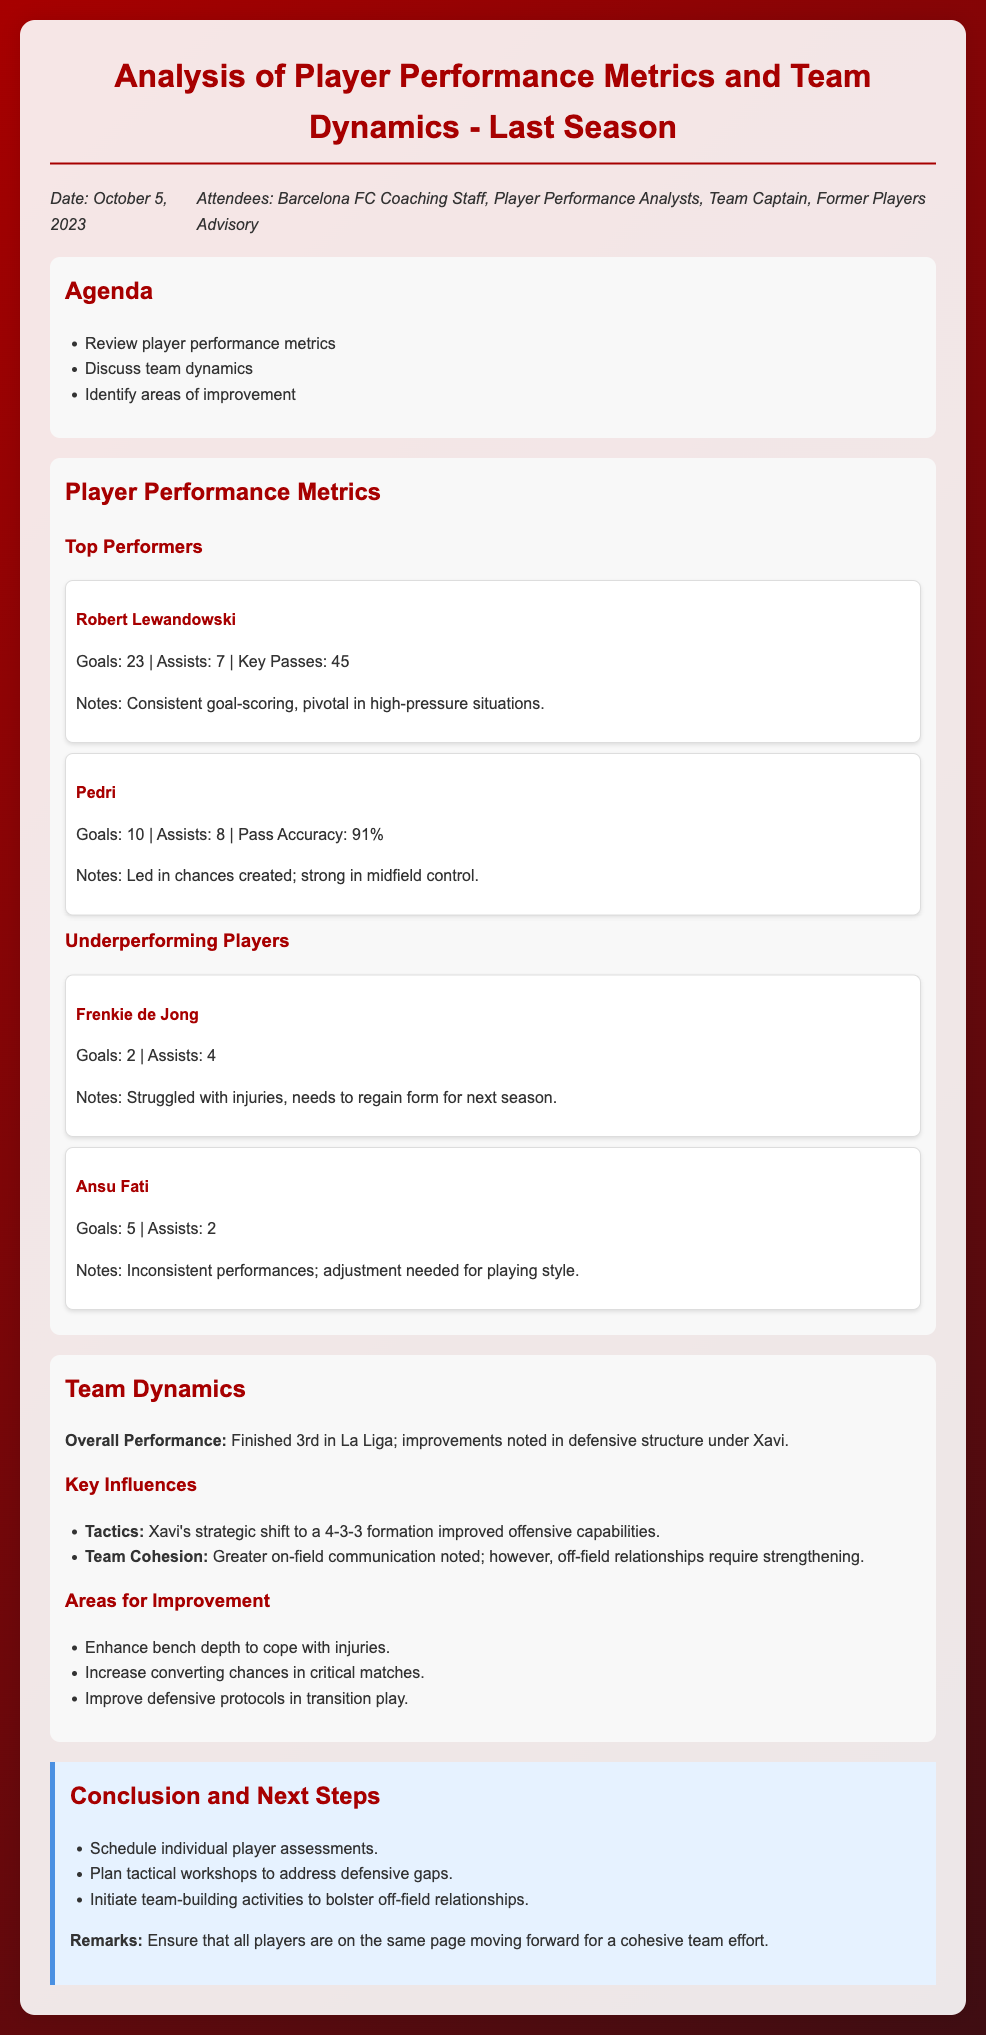What was the date of the meeting? The date of the meeting is explicitly mentioned in the document under the date-attendees section.
Answer: October 5, 2023 Who was identified as a top performer in goals scored? The document highlights Robert Lewandowski as a top performer, mentioning his goal count.
Answer: Robert Lewandowski What formation did Xavi shift to? The document specifies Xavi's tactical shift, indicating the formation used by the team.
Answer: 4-3-3 How many assists did Pedri have? The document provides specific statistics for Pedri's assists in the player performance metrics section.
Answer: 8 What is one area for improvement mentioned in the document? The conclusion section lists areas that require attention, which includes issues regarding team performance.
Answer: Enhance bench depth What position did the team finish in La Liga? The overall performance section reviews the team's standing in La Liga during the season.
Answer: 3rd Which player struggled with injuries? One of the players noted in the underperforming section had a mention of injury troubles.
Answer: Frenkie de Jong How many key passes did Robert Lewandowski make? The metrics section specifies the number of key passes made by Lewandowski during the season.
Answer: 45 